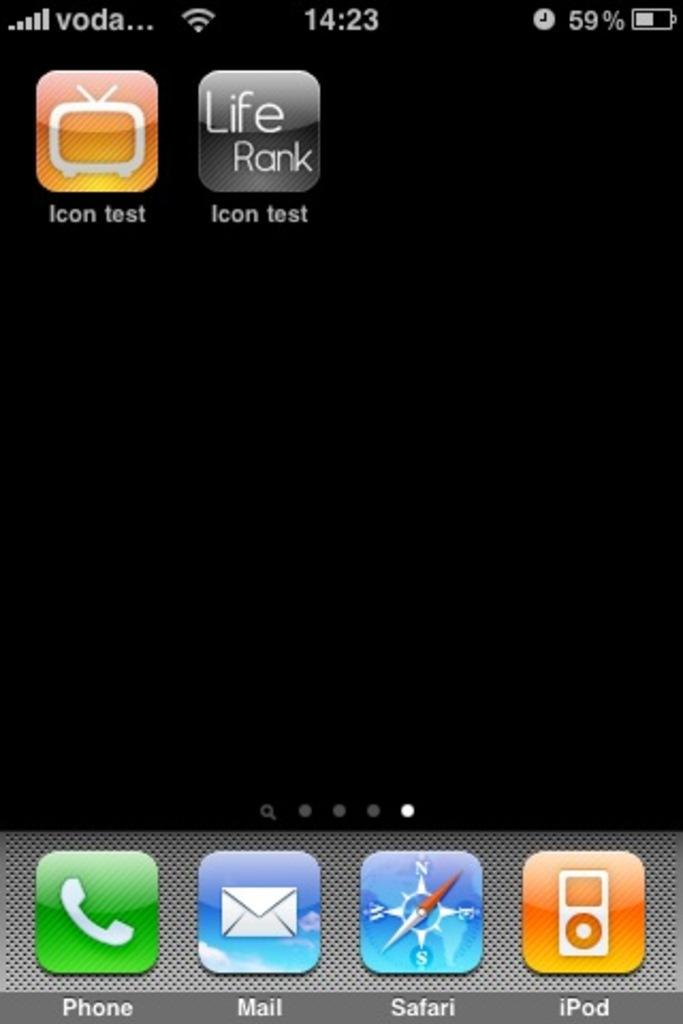Provide a one-sentence caption for the provided image. A smartphone screen shows icon test for the apps. 